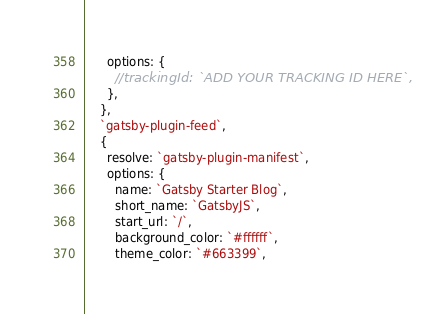Convert code to text. <code><loc_0><loc_0><loc_500><loc_500><_JavaScript_>      options: {
        //trackingId: `ADD YOUR TRACKING ID HERE`,
      },
    },
    `gatsby-plugin-feed`,
    {
      resolve: `gatsby-plugin-manifest`,
      options: {
        name: `Gatsby Starter Blog`,
        short_name: `GatsbyJS`,
        start_url: `/`,
        background_color: `#ffffff`,
        theme_color: `#663399`,</code> 